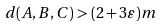<formula> <loc_0><loc_0><loc_500><loc_500>d ( A , B , C ) > ( 2 + 3 \varepsilon ) m</formula> 